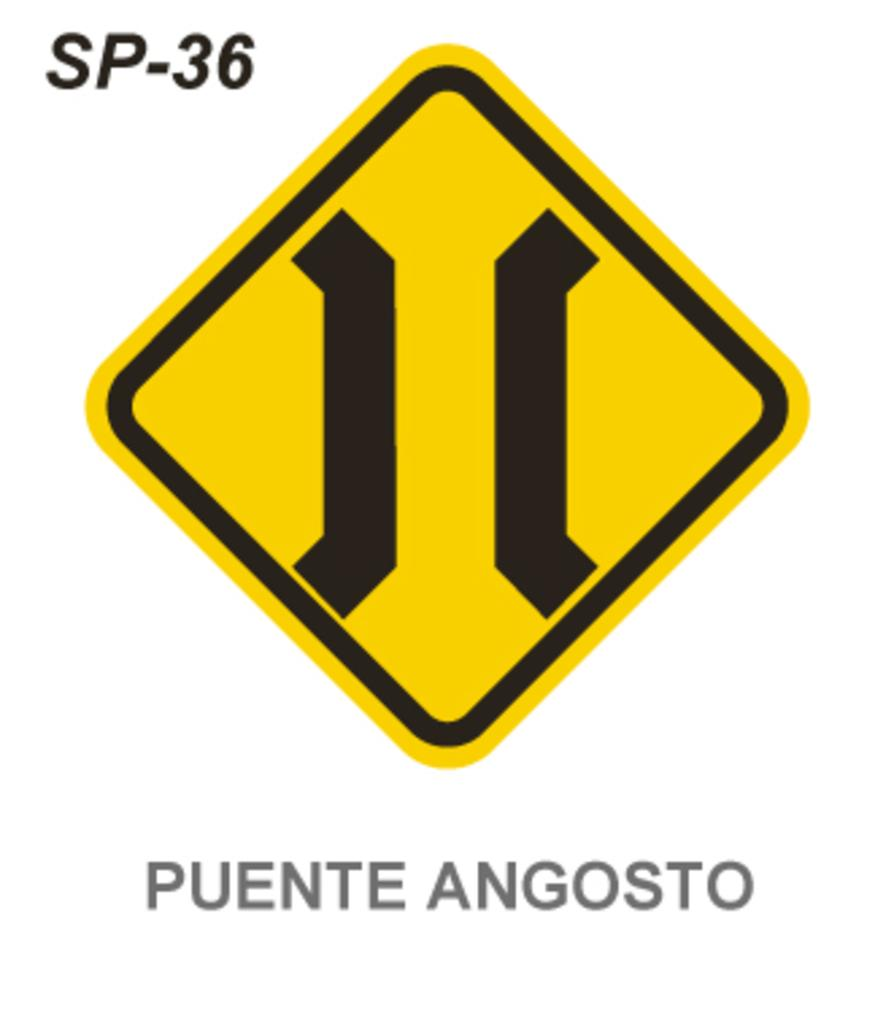<image>
Give a short and clear explanation of the subsequent image. A diamond shaped yellow road sign that says Puente Angosto on it. 